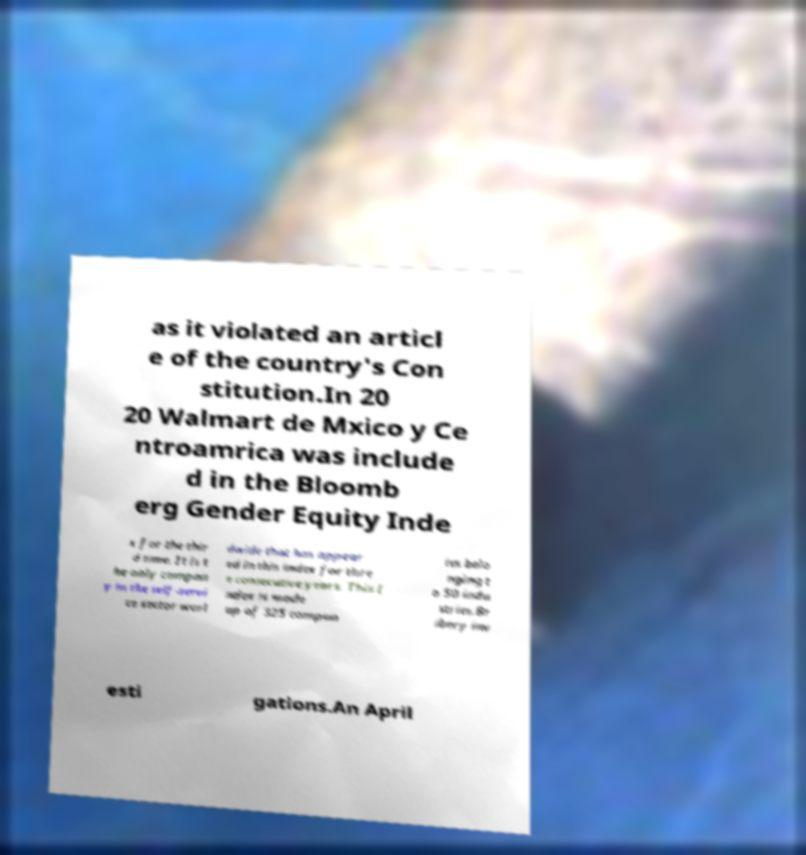There's text embedded in this image that I need extracted. Can you transcribe it verbatim? as it violated an articl e of the country's Con stitution.In 20 20 Walmart de Mxico y Ce ntroamrica was include d in the Bloomb erg Gender Equity Inde x for the thir d time. It is t he only compan y in the self-servi ce sector worl dwide that has appear ed in this index for thre e consecutive years. This I ndex is made up of 325 compan ies belo nging t o 50 indu stries.Br ibery inv esti gations.An April 